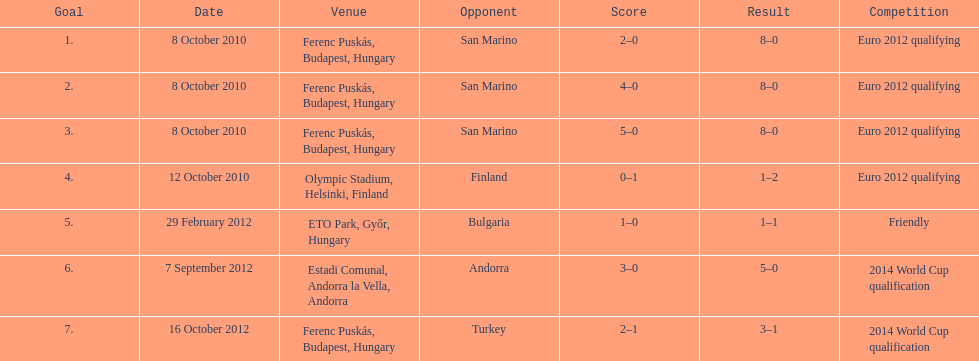In how many contests did he score, yet his team lost? 1. 